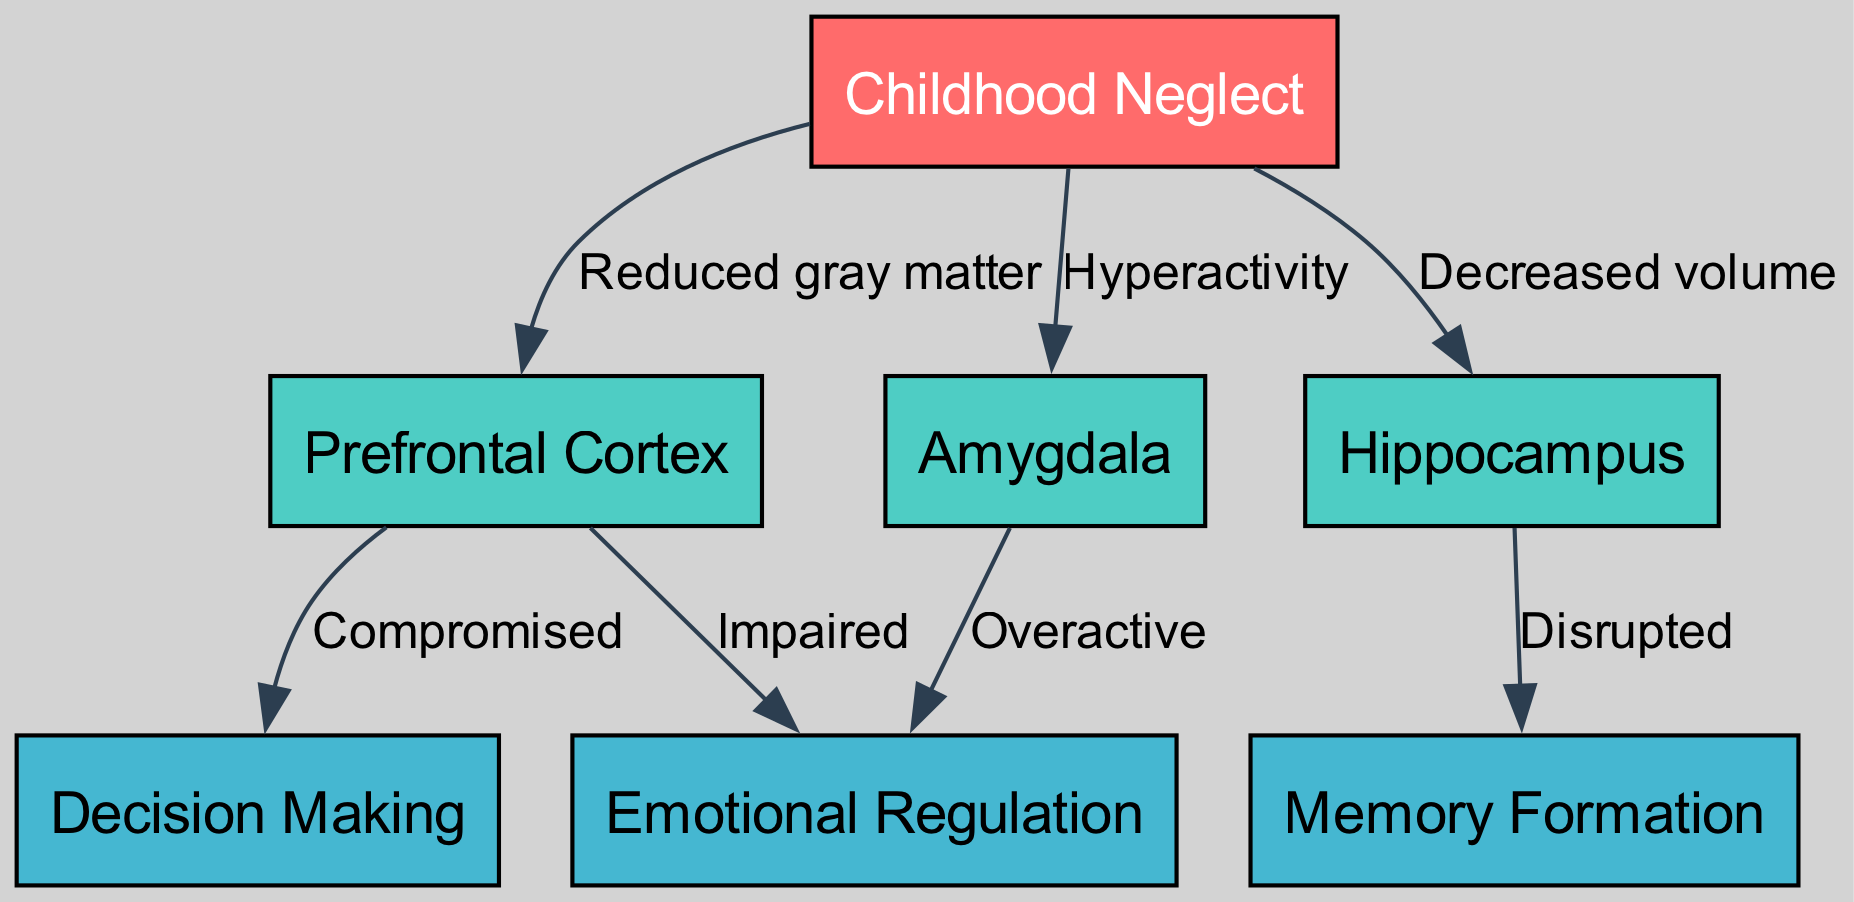What is the primary effect of childhood neglect on the prefrontal cortex? The diagram shows that childhood neglect leads to "Reduced gray matter" in the prefrontal cortex. This connection is explicitly labeled in the edge between the "Childhood Neglect" node and the "Prefrontal Cortex" node.
Answer: Reduced gray matter How many nodes are present in the diagram? By counting the total number of unique labeled nodes shown in the diagram, we see there are seven different nodes representing various aspects related to childhood neglect and its effects.
Answer: 7 What is the relationship between the amygdala and emotional regulation? The diagram indicates that childhood neglect causes the amygdala to become "Overactive," which subsequently leads to "Impaired" emotional regulation. The edges connecting these nodes detail this relationship.
Answer: Overactive What effect does childhood neglect have on the hippocampus? According to the diagram, childhood neglect results in "Decreased volume" in the hippocampus, which is directly shown via the edge labeled with this effect between the "Childhood Neglect" node and the "Hippocampus" node.
Answer: Decreased volume Which node is compromised by the prefrontal cortex? The edge from the prefrontal cortex to the decision-making node indicates a "Compromised" relationship, meaning the decision-making capability is negatively impacted due to the prefrontal cortex condition.
Answer: Compromised What type of node is the "Hippocampus"? The "Hippocampus" is categorized as a neural structure affected by childhood neglect, as indicated in the diagram connecting it with the types of cognitive functioning such as memory formation. It serves as an essential component in describing the overarching effects on cognitive abilities.
Answer: Neural structure How many edges are there representing relationships from "Childhood Neglect"? By examining the edges that start from the "Childhood Neglect" node and lead to other nodes, we identify three distinct edges that illustrate specific effects on other areas such as the prefrontal cortex, amygdala, and hippocampus.
Answer: 3 What is disrupted as a result of the hippocampus's condition? The diagram specifies that the condition of the hippocampus due to childhood neglect leads to "Disrupted" memory formation, shown by the edge connecting these two nodes.
Answer: Disrupted What does childhood neglect lead to in the context of decision making? The edge indicates that childhood neglect causes "Compromised" decision making through its impact on the prefrontal cortex, showcasing how this area affects overall decision-making abilities.
Answer: Compromised 